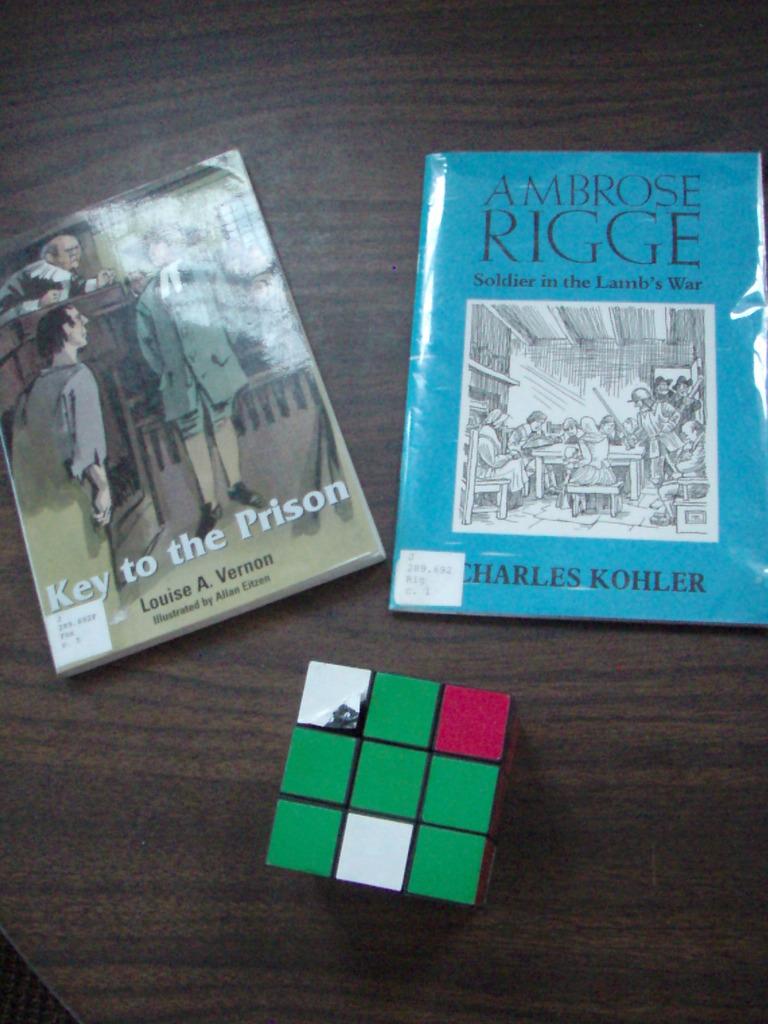Who is the author of the book on the right?
Offer a very short reply. Charles kohler. What is the title of the book on the left?
Offer a terse response. Key to the prison. 